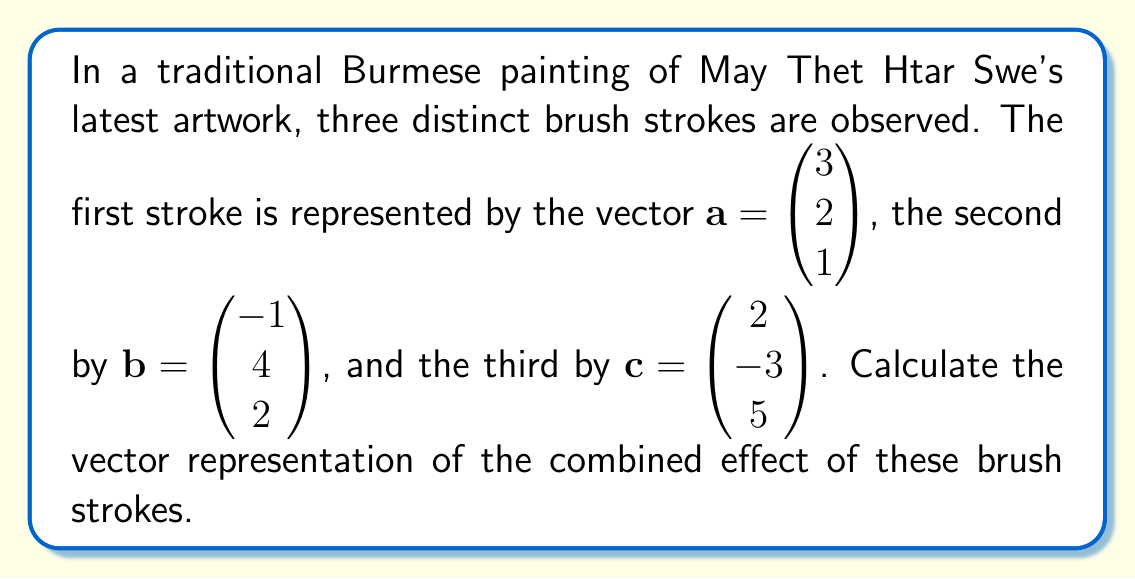Help me with this question. To find the combined effect of the brush strokes, we need to add the three vectors representing each stroke. This is done by adding the corresponding components of each vector.

1) First, let's write out the vectors:
   $\mathbf{a} = \begin{pmatrix} 3 \\ 2 \\ 1 \end{pmatrix}$, 
   $\mathbf{b} = \begin{pmatrix} -1 \\ 4 \\ 2 \end{pmatrix}$, 
   $\mathbf{c} = \begin{pmatrix} 2 \\ -3 \\ 5 \end{pmatrix}$

2) Now, we add these vectors:
   $\mathbf{a} + \mathbf{b} + \mathbf{c} = \begin{pmatrix} 3 \\ 2 \\ 1 \end{pmatrix} + \begin{pmatrix} -1 \\ 4 \\ 2 \end{pmatrix} + \begin{pmatrix} 2 \\ -3 \\ 5 \end{pmatrix}$

3) Adding the corresponding components:
   $= \begin{pmatrix} 3 + (-1) + 2 \\ 2 + 4 + (-3) \\ 1 + 2 + 5 \end{pmatrix}$

4) Simplifying:
   $= \begin{pmatrix} 4 \\ 3 \\ 8 \end{pmatrix}$

Therefore, the vector representation of the combined effect of these brush strokes is $\begin{pmatrix} 4 \\ 3 \\ 8 \end{pmatrix}$.
Answer: $\begin{pmatrix} 4 \\ 3 \\ 8 \end{pmatrix}$ 